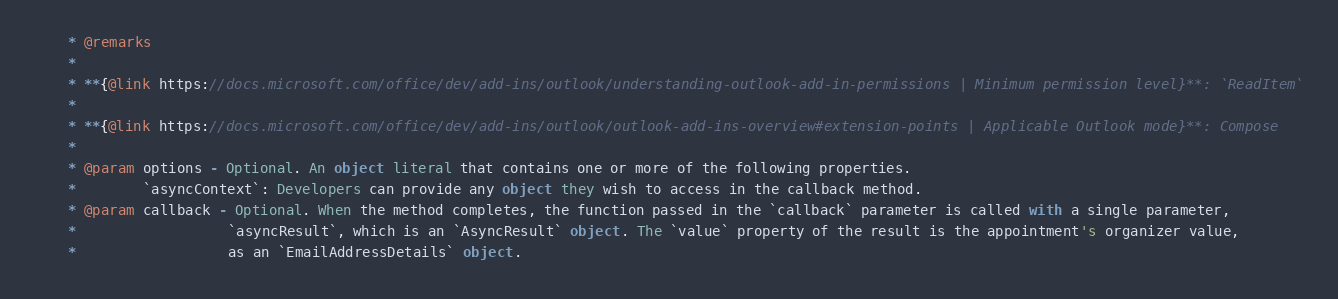Convert code to text. <code><loc_0><loc_0><loc_500><loc_500><_Scala_>    * @remarks
    * 
    * **{@link https://docs.microsoft.com/office/dev/add-ins/outlook/understanding-outlook-add-in-permissions | Minimum permission level}**: `ReadItem`
    * 
    * **{@link https://docs.microsoft.com/office/dev/add-ins/outlook/outlook-add-ins-overview#extension-points | Applicable Outlook mode}**: Compose
    * 
    * @param options - Optional. An object literal that contains one or more of the following properties.
    *        `asyncContext`: Developers can provide any object they wish to access in the callback method.
    * @param callback - Optional. When the method completes, the function passed in the `callback` parameter is called with a single parameter,
    *                  `asyncResult`, which is an `AsyncResult` object. The `value` property of the result is the appointment's organizer value,
    *                  as an `EmailAddressDetails` object.</code> 